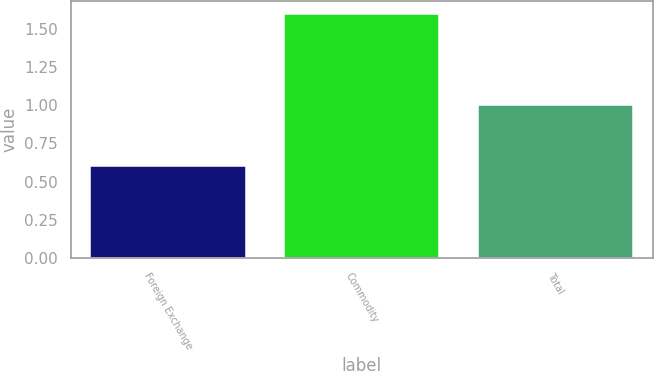Convert chart. <chart><loc_0><loc_0><loc_500><loc_500><bar_chart><fcel>Foreign Exchange<fcel>Commodity<fcel>Total<nl><fcel>0.6<fcel>1.6<fcel>1<nl></chart> 